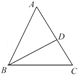Given an angle bisector BD in triangle ABC, where angle DBA is represented by the variable p degrees and angle ADB is denoted by q degrees, express the measure of angle C in terms of p and q. To solve for the measure of angle C, we start by noting that angle C is the supplement of angles A and B in triangle ABC, due to the triangle angle sum property. Since BD is an angle bisector, angle DBA = p degrees and angle ADB = q degrees, thus angle ADB = q degrees. The entire angle at B, which is angle ABC, is just the sum of these two, which is p + q degrees. Since the sum of angles in any triangle is 180 degrees, angle C can be computed as 180 - (p + q) degrees. Therefore, angle C = 180 - (p + q) degrees, which clearly explains the measure in terms of p and q. 